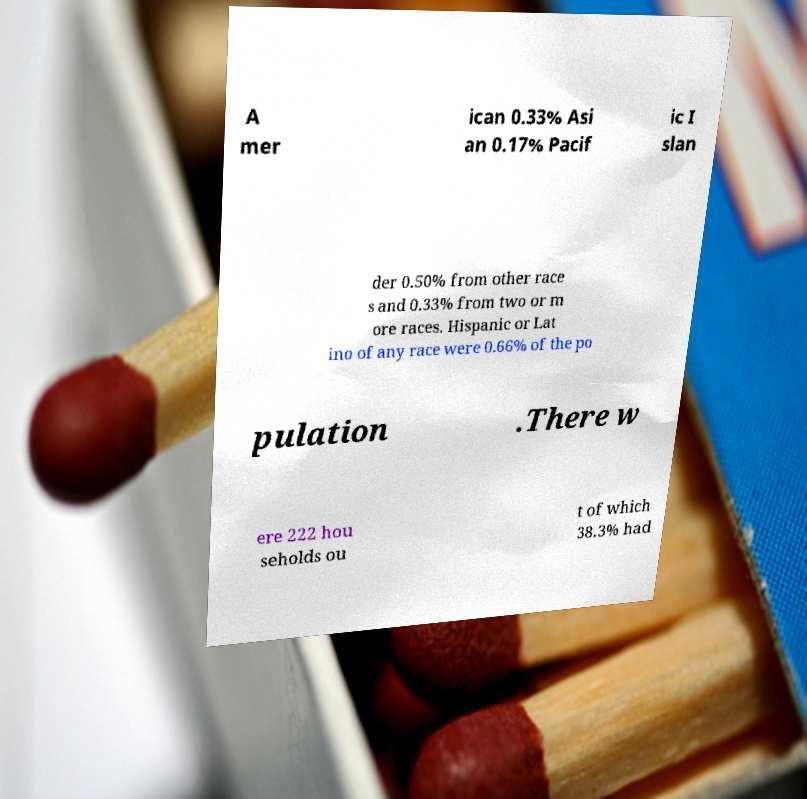Could you extract and type out the text from this image? A mer ican 0.33% Asi an 0.17% Pacif ic I slan der 0.50% from other race s and 0.33% from two or m ore races. Hispanic or Lat ino of any race were 0.66% of the po pulation .There w ere 222 hou seholds ou t of which 38.3% had 